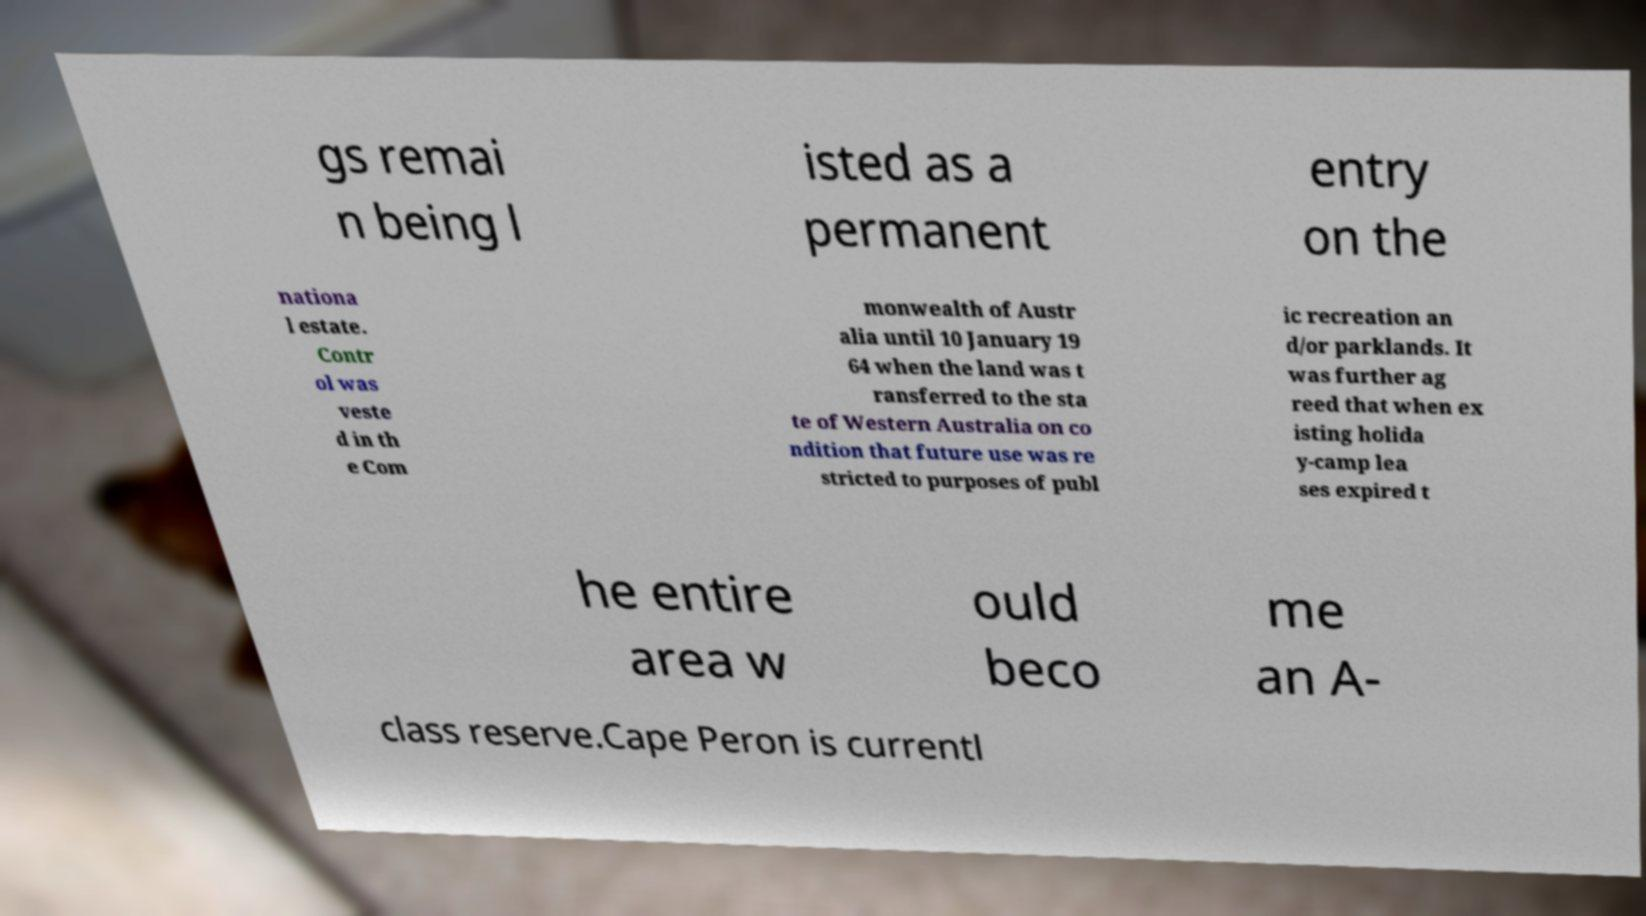Could you extract and type out the text from this image? gs remai n being l isted as a permanent entry on the nationa l estate. Contr ol was veste d in th e Com monwealth of Austr alia until 10 January 19 64 when the land was t ransferred to the sta te of Western Australia on co ndition that future use was re stricted to purposes of publ ic recreation an d/or parklands. It was further ag reed that when ex isting holida y-camp lea ses expired t he entire area w ould beco me an A- class reserve.Cape Peron is currentl 